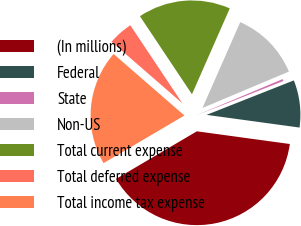Convert chart to OTSL. <chart><loc_0><loc_0><loc_500><loc_500><pie_chart><fcel>(In millions)<fcel>Federal<fcel>State<fcel>Non-US<fcel>Total current expense<fcel>Total deferred expense<fcel>Total income tax expense<nl><fcel>39.37%<fcel>8.15%<fcel>0.35%<fcel>12.06%<fcel>15.96%<fcel>4.25%<fcel>19.86%<nl></chart> 